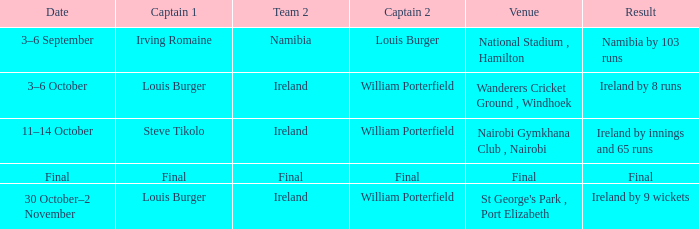Which Result has a Captain 1 of louis burger, and a Date of 30 october–2 november? Ireland by 9 wickets. 